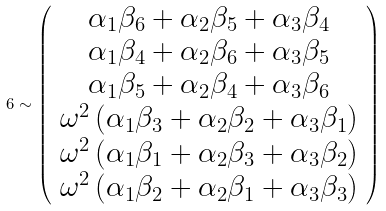Convert formula to latex. <formula><loc_0><loc_0><loc_500><loc_500>6 \sim \left ( \begin{array} { c } \alpha _ { 1 } \beta _ { 6 } + \alpha _ { 2 } \beta _ { 5 } + \alpha _ { 3 } \beta _ { 4 } \\ \alpha _ { 1 } \beta _ { 4 } + \alpha _ { 2 } \beta _ { 6 } + \alpha _ { 3 } \beta _ { 5 } \\ \alpha _ { 1 } \beta _ { 5 } + \alpha _ { 2 } \beta _ { 4 } + \alpha _ { 3 } \beta _ { 6 } \\ \omega ^ { 2 } \left ( \alpha _ { 1 } \beta _ { 3 } + \alpha _ { 2 } \beta _ { 2 } + \alpha _ { 3 } \beta _ { 1 } \right ) \\ \omega ^ { 2 } \left ( \alpha _ { 1 } \beta _ { 1 } + \alpha _ { 2 } \beta _ { 3 } + \alpha _ { 3 } \beta _ { 2 } \right ) \\ \omega ^ { 2 } \left ( \alpha _ { 1 } \beta _ { 2 } + \alpha _ { 2 } \beta _ { 1 } + \alpha _ { 3 } \beta _ { 3 } \right ) \end{array} \right )</formula> 